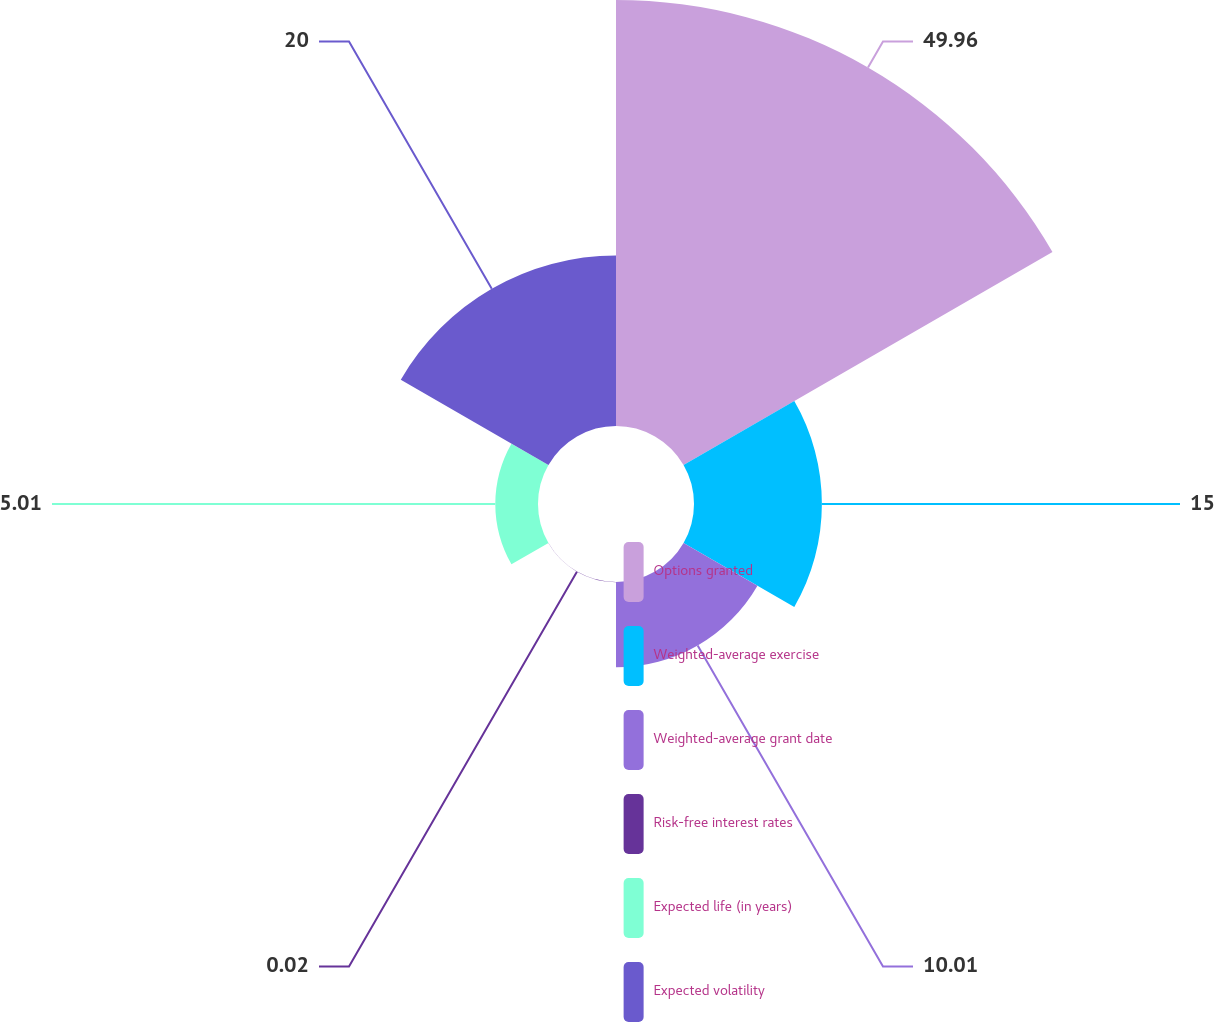Convert chart. <chart><loc_0><loc_0><loc_500><loc_500><pie_chart><fcel>Options granted<fcel>Weighted-average exercise<fcel>Weighted-average grant date<fcel>Risk-free interest rates<fcel>Expected life (in years)<fcel>Expected volatility<nl><fcel>49.97%<fcel>15.0%<fcel>10.01%<fcel>0.02%<fcel>5.01%<fcel>20.0%<nl></chart> 